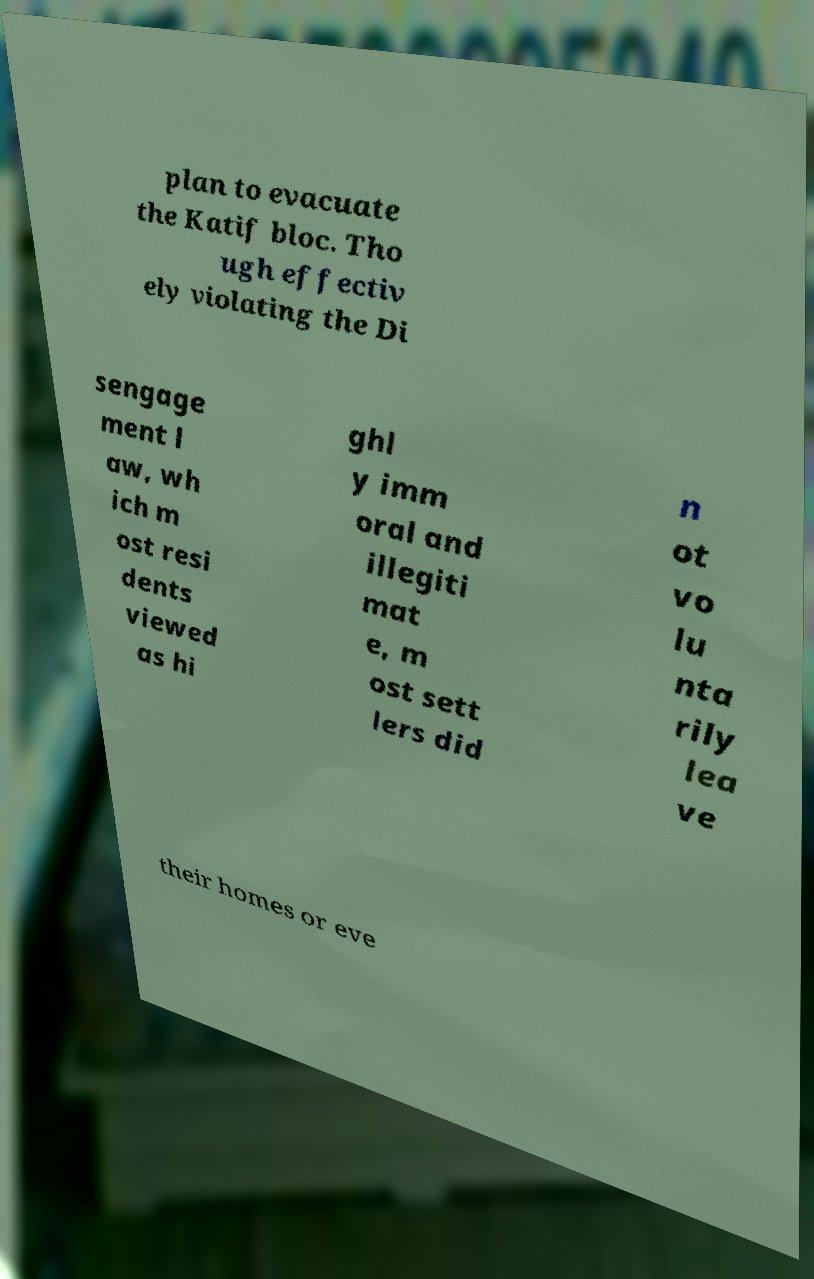For documentation purposes, I need the text within this image transcribed. Could you provide that? plan to evacuate the Katif bloc. Tho ugh effectiv ely violating the Di sengage ment l aw, wh ich m ost resi dents viewed as hi ghl y imm oral and illegiti mat e, m ost sett lers did n ot vo lu nta rily lea ve their homes or eve 